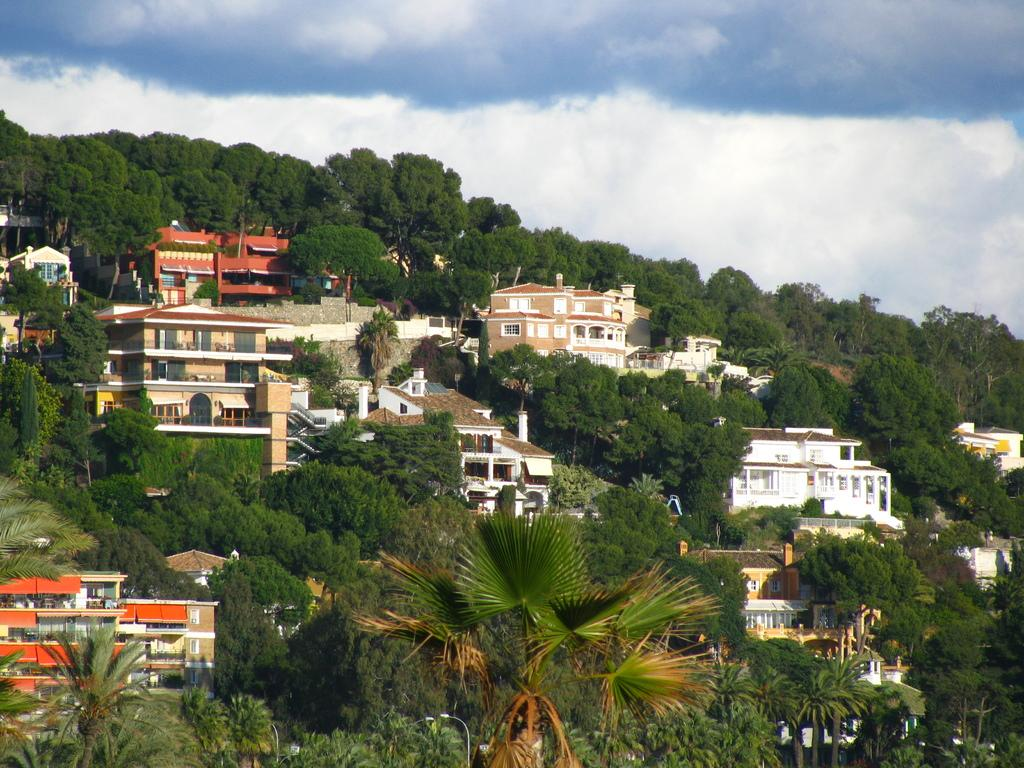What is the primary feature of the landscape in the image? There are a lot of trees in the image. What structures can be seen among the trees? There are buildings and houses in between the trees. Can you describe the relationship between the trees and the structures in the image? The buildings and houses are interspersed among the trees. What type of soup is being served in the image? There is no soup present in the image; it primarily features trees, buildings, and houses. 